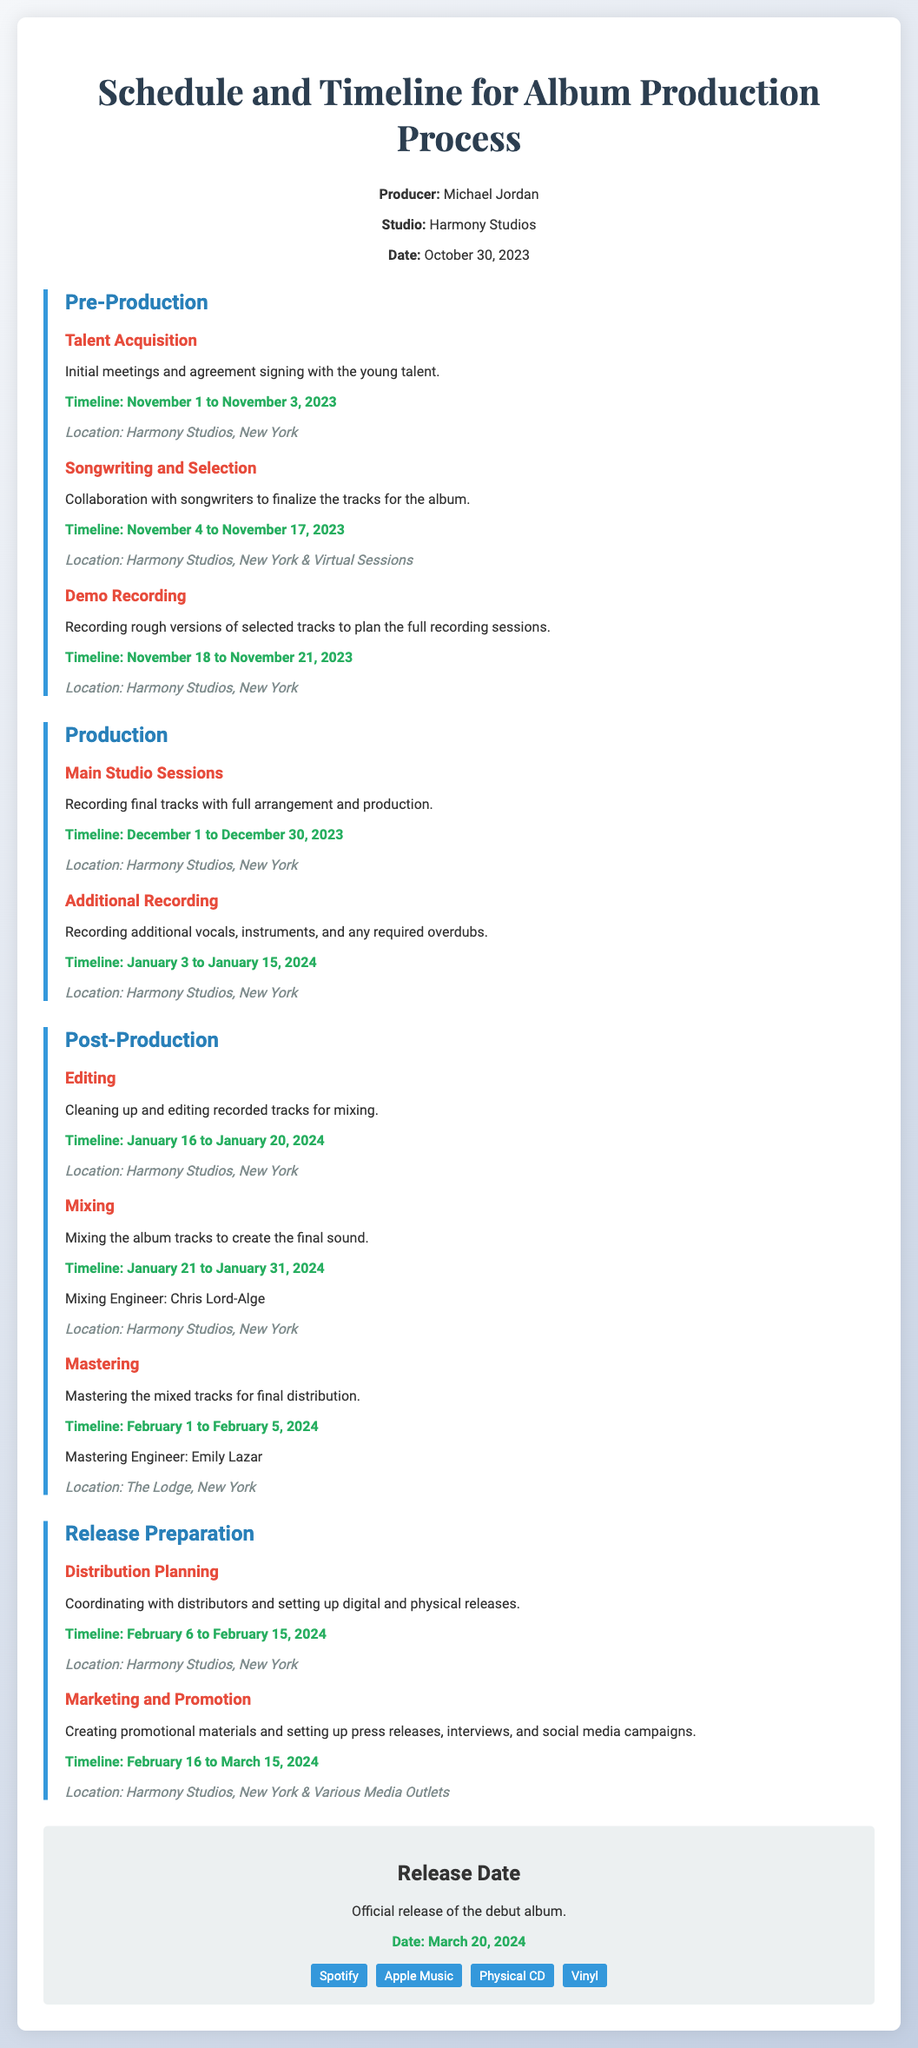What are the names of the mastering and mixing engineers? The document specifies the names of the engineers for each process, which are Chris Lord-Alge for mixing and Emily Lazar for mastering.
Answer: Chris Lord-Alge, Emily Lazar What is the timeline for demo recording? The document states the timeline for the demo recording process is November 18 to November 21, 2023.
Answer: November 18 to November 21, 2023 Where will the main studio sessions take place? According to the document, the main studio sessions will occur at Harmony Studios in New York.
Answer: Harmony Studios, New York What is the release date of the debut album? The document clearly states the official release date of the debut album is March 20, 2024.
Answer: March 20, 2024 What stage follows the main studio sessions? The document outlines that the stage following the main studio sessions is additional recording.
Answer: Additional Recording What locations are mentioned for distribution planning? The locations mentioned for distribution planning include Harmony Studios in New York.
Answer: Harmony Studios, New York How long will the editing process last? The timeline in the document indicates that the editing process will last from January 16 to January 20, 2024.
Answer: January 16 to January 20, 2024 What is the purpose of the pre-production section? The purpose of the pre-production section is to prepare for the album by acquiring talent, songwriting, and demo recording.
Answer: Talent Acquisition, Songwriting, Demo Recording What is the total duration for marketing and promotion? The document specifies the marketing and promotion timeline is from February 16 to March 15, 2024, which spans a month.
Answer: February 16 to March 15, 2024 